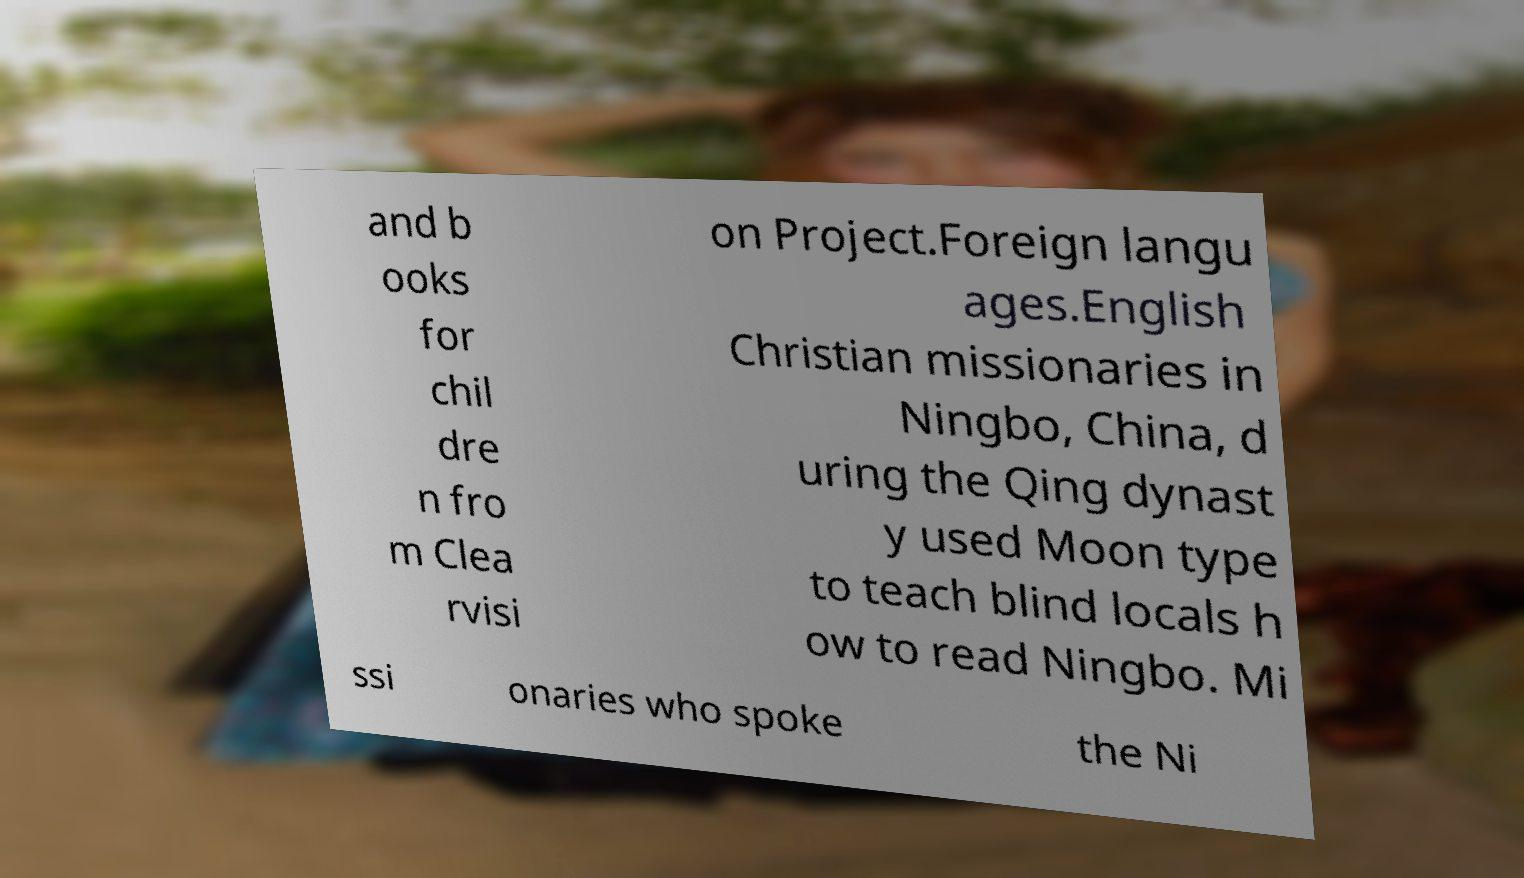I need the written content from this picture converted into text. Can you do that? and b ooks for chil dre n fro m Clea rvisi on Project.Foreign langu ages.English Christian missionaries in Ningbo, China, d uring the Qing dynast y used Moon type to teach blind locals h ow to read Ningbo. Mi ssi onaries who spoke the Ni 